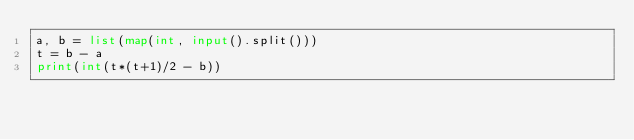Convert code to text. <code><loc_0><loc_0><loc_500><loc_500><_Python_>a, b = list(map(int, input().split()))
t = b - a
print(int(t*(t+1)/2 - b))</code> 